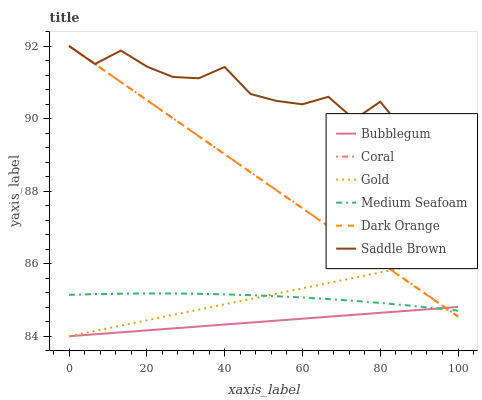Does Bubblegum have the minimum area under the curve?
Answer yes or no. Yes. Does Saddle Brown have the maximum area under the curve?
Answer yes or no. Yes. Does Gold have the minimum area under the curve?
Answer yes or no. No. Does Gold have the maximum area under the curve?
Answer yes or no. No. Is Dark Orange the smoothest?
Answer yes or no. Yes. Is Saddle Brown the roughest?
Answer yes or no. Yes. Is Gold the smoothest?
Answer yes or no. No. Is Gold the roughest?
Answer yes or no. No. Does Gold have the lowest value?
Answer yes or no. Yes. Does Coral have the lowest value?
Answer yes or no. No. Does Saddle Brown have the highest value?
Answer yes or no. Yes. Does Gold have the highest value?
Answer yes or no. No. Is Gold less than Saddle Brown?
Answer yes or no. Yes. Is Saddle Brown greater than Medium Seafoam?
Answer yes or no. Yes. Does Dark Orange intersect Medium Seafoam?
Answer yes or no. Yes. Is Dark Orange less than Medium Seafoam?
Answer yes or no. No. Is Dark Orange greater than Medium Seafoam?
Answer yes or no. No. Does Gold intersect Saddle Brown?
Answer yes or no. No. 